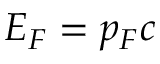Convert formula to latex. <formula><loc_0><loc_0><loc_500><loc_500>E _ { F } = p _ { F } c</formula> 